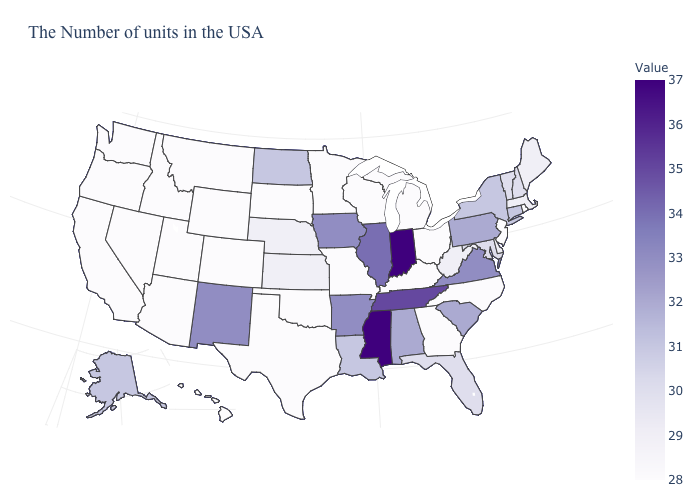Does Ohio have the lowest value in the USA?
Keep it brief. Yes. Is the legend a continuous bar?
Quick response, please. Yes. Which states hav the highest value in the South?
Keep it brief. Mississippi. 